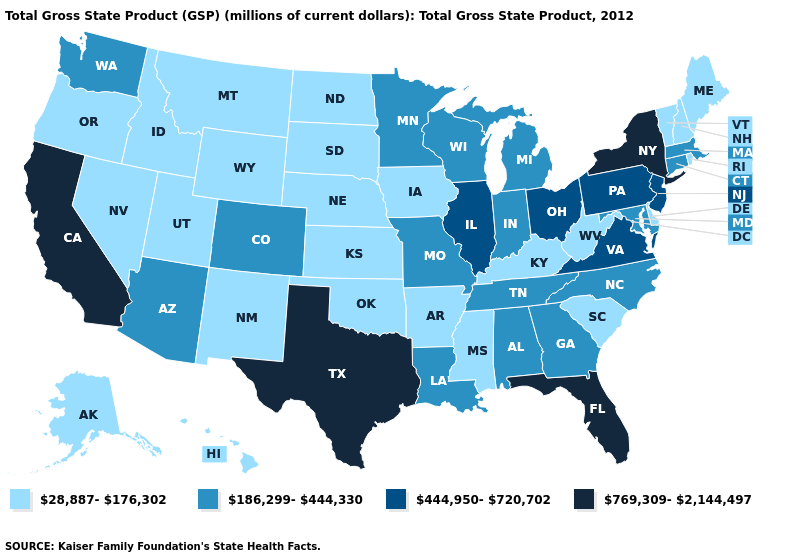What is the value of California?
Concise answer only. 769,309-2,144,497. What is the value of Louisiana?
Short answer required. 186,299-444,330. Among the states that border Michigan , does Ohio have the lowest value?
Keep it brief. No. Which states have the lowest value in the MidWest?
Short answer required. Iowa, Kansas, Nebraska, North Dakota, South Dakota. Which states have the lowest value in the USA?
Concise answer only. Alaska, Arkansas, Delaware, Hawaii, Idaho, Iowa, Kansas, Kentucky, Maine, Mississippi, Montana, Nebraska, Nevada, New Hampshire, New Mexico, North Dakota, Oklahoma, Oregon, Rhode Island, South Carolina, South Dakota, Utah, Vermont, West Virginia, Wyoming. Name the states that have a value in the range 186,299-444,330?
Write a very short answer. Alabama, Arizona, Colorado, Connecticut, Georgia, Indiana, Louisiana, Maryland, Massachusetts, Michigan, Minnesota, Missouri, North Carolina, Tennessee, Washington, Wisconsin. Does Michigan have the same value as Nebraska?
Short answer required. No. What is the lowest value in states that border Alabama?
Write a very short answer. 28,887-176,302. Name the states that have a value in the range 186,299-444,330?
Keep it brief. Alabama, Arizona, Colorado, Connecticut, Georgia, Indiana, Louisiana, Maryland, Massachusetts, Michigan, Minnesota, Missouri, North Carolina, Tennessee, Washington, Wisconsin. What is the value of Oklahoma?
Answer briefly. 28,887-176,302. Name the states that have a value in the range 186,299-444,330?
Give a very brief answer. Alabama, Arizona, Colorado, Connecticut, Georgia, Indiana, Louisiana, Maryland, Massachusetts, Michigan, Minnesota, Missouri, North Carolina, Tennessee, Washington, Wisconsin. What is the value of Tennessee?
Concise answer only. 186,299-444,330. What is the lowest value in states that border New Mexico?
Keep it brief. 28,887-176,302. Among the states that border Iowa , which have the lowest value?
Give a very brief answer. Nebraska, South Dakota. Name the states that have a value in the range 444,950-720,702?
Keep it brief. Illinois, New Jersey, Ohio, Pennsylvania, Virginia. 